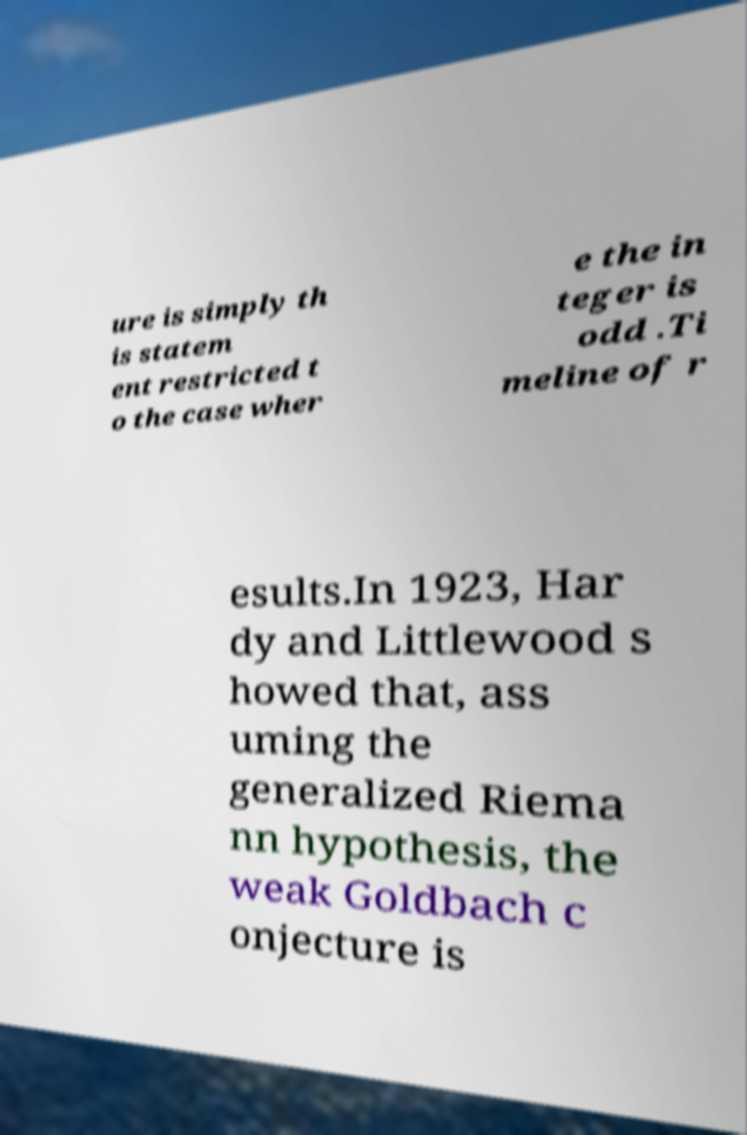I need the written content from this picture converted into text. Can you do that? ure is simply th is statem ent restricted t o the case wher e the in teger is odd .Ti meline of r esults.In 1923, Har dy and Littlewood s howed that, ass uming the generalized Riema nn hypothesis, the weak Goldbach c onjecture is 